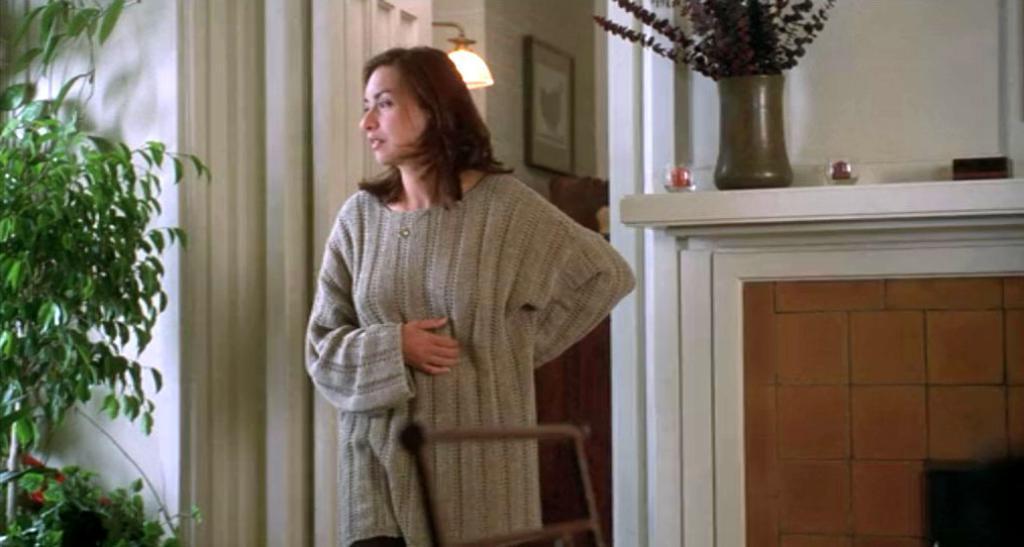How would you summarize this image in a sentence or two? There is a lady, chair and a plant in the foreground area of the image, there are windows, framed, other objects and curtains in the background. 